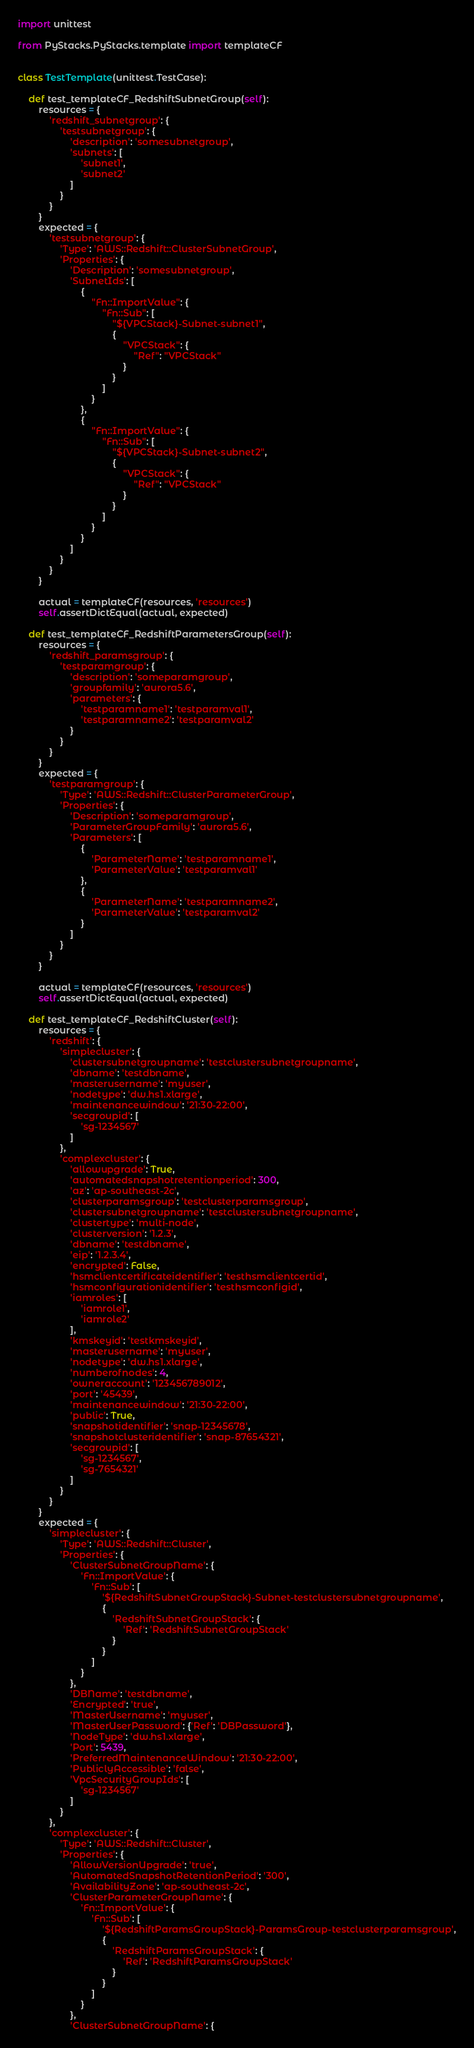Convert code to text. <code><loc_0><loc_0><loc_500><loc_500><_Python_>import unittest

from PyStacks.PyStacks.template import templateCF


class TestTemplate(unittest.TestCase):

    def test_templateCF_RedshiftSubnetGroup(self):
        resources = {
            'redshift_subnetgroup': {
                'testsubnetgroup': {
                    'description': 'somesubnetgroup',
                    'subnets': [
                        'subnet1',
                        'subnet2'
                    ]
                }
            }
        }
        expected = {
            'testsubnetgroup': {
                'Type': 'AWS::Redshift::ClusterSubnetGroup',
                'Properties': {
                    'Description': 'somesubnetgroup',
                    'SubnetIds': [
                        {
                            "Fn::ImportValue": {
                                "Fn::Sub": [
                                    "${VPCStack}-Subnet-subnet1",
                                    {
                                        "VPCStack": {
                                            "Ref": "VPCStack"
                                        }
                                    }
                                ]
                            }
                        },
                        {
                            "Fn::ImportValue": {
                                "Fn::Sub": [
                                    "${VPCStack}-Subnet-subnet2",
                                    {
                                        "VPCStack": {
                                            "Ref": "VPCStack"
                                        }
                                    }
                                ]
                            }
                        }
                    ]
                }
            }
        }

        actual = templateCF(resources, 'resources')
        self.assertDictEqual(actual, expected)

    def test_templateCF_RedshiftParametersGroup(self):
        resources = {
            'redshift_paramsgroup': {
                'testparamgroup': {
                    'description': 'someparamgroup',
                    'groupfamily': 'aurora5.6',
                    'parameters': {
                        'testparamname1': 'testparamval1',
                        'testparamname2': 'testparamval2'
                    }
                }
            }
        }
        expected = {
            'testparamgroup': {
                'Type': 'AWS::Redshift::ClusterParameterGroup',
                'Properties': {
                    'Description': 'someparamgroup',
                    'ParameterGroupFamily': 'aurora5.6',
                    'Parameters': [
                        {
                            'ParameterName': 'testparamname1',
                            'ParameterValue': 'testparamval1'
                        },
                        {
                            'ParameterName': 'testparamname2',
                            'ParameterValue': 'testparamval2'
                        }
                    ]
                }
            }
        }

        actual = templateCF(resources, 'resources')
        self.assertDictEqual(actual, expected)

    def test_templateCF_RedshiftCluster(self):
        resources = {
            'redshift': {
                'simplecluster': {
                    'clustersubnetgroupname': 'testclustersubnetgroupname',
                    'dbname': 'testdbname',
                    'masterusername': 'myuser',
                    'nodetype': 'dw.hs1.xlarge',
                    'maintenancewindow': '21:30-22:00',
                    'secgroupid': [
                        'sg-1234567'
                    ]
                },
                'complexcluster': {
                    'allowupgrade': True,
                    'automatedsnapshotretentionperiod': 300,
                    'az': 'ap-southeast-2c',
                    'clusterparamsgroup': 'testclusterparamsgroup',
                    'clustersubnetgroupname': 'testclustersubnetgroupname',
                    'clustertype': 'multi-node',
                    'clusterversion': '1.2.3',
                    'dbname': 'testdbname',
                    'eip': '1.2.3.4',
                    'encrypted': False,
                    'hsmclientcertificateidentifier': 'testhsmclientcertid',
                    'hsmconfigurationidentifier': 'testhsmconfigid',
                    'iamroles': [
                        'iamrole1',
                        'iamrole2'
                    ],
                    'kmskeyid': 'testkmskeyid',
                    'masterusername': 'myuser',
                    'nodetype': 'dw.hs1.xlarge',
                    'numberofnodes': 4,
                    'owneraccount': '123456789012',
                    'port': '45439',
                    'maintenancewindow': '21:30-22:00',
                    'public': True,
                    'snapshotidentifier': 'snap-12345678',
                    'snapshotclusteridentifier': 'snap-87654321',
                    'secgroupid': [
                        'sg-1234567',
                        'sg-7654321'
                    ]
                }
            }
        }
        expected = {
            'simplecluster': {
                'Type': 'AWS::Redshift::Cluster',
                'Properties': {
                    'ClusterSubnetGroupName': {
                        'Fn::ImportValue': {
                            'Fn::Sub': [
                                '${RedshiftSubnetGroupStack}-Subnet-testclustersubnetgroupname',
                                {
                                    'RedshiftSubnetGroupStack': {
                                        'Ref': 'RedshiftSubnetGroupStack'
                                    }
                                }
                            ]
                        }
                    },
                    'DBName': 'testdbname',
                    'Encrypted': 'true',
                    'MasterUsername': 'myuser',
                    'MasterUserPassword': {'Ref': 'DBPassword'},
                    'NodeType': 'dw.hs1.xlarge',
                    'Port': 5439,
                    'PreferredMaintenanceWindow': '21:30-22:00',
                    'PubliclyAccessible': 'false',
                    'VpcSecurityGroupIds': [
                        'sg-1234567'
                    ]
                }
            },
            'complexcluster': {
                'Type': 'AWS::Redshift::Cluster',
                'Properties': {
                    'AllowVersionUpgrade': 'true',
                    'AutomatedSnapshotRetentionPeriod': '300',
                    'AvailabilityZone': 'ap-southeast-2c',
                    'ClusterParameterGroupName': {
                        'Fn::ImportValue': {
                            'Fn::Sub': [
                                '${RedshiftParamsGroupStack}-ParamsGroup-testclusterparamsgroup',
                                {
                                    'RedshiftParamsGroupStack': {
                                        'Ref': 'RedshiftParamsGroupStack'
                                    }
                                }
                            ]
                        }
                    },
                    'ClusterSubnetGroupName': {</code> 